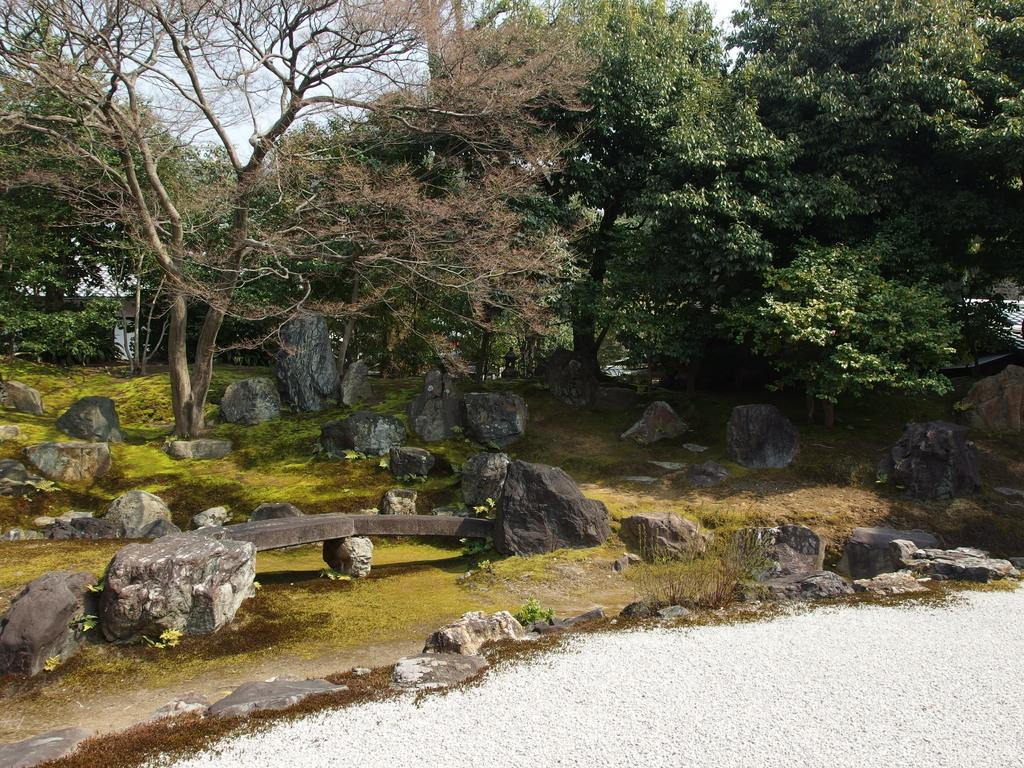What type of vegetation can be seen in the image? There are trees in the image. What other natural elements are present in the image? There are rocks in the image. What is at the bottom of the image? There is grass at the bottom of the image. What is visible at the top of the image? The sky is visible at the top of the image. What type of pancake is being used as a prop in the image? There is no pancake present in the image; it features trees, rocks, grass, and the sky. How does the cracker demand attention in the image? There is no cracker present in the image, so it cannot demand attention. 